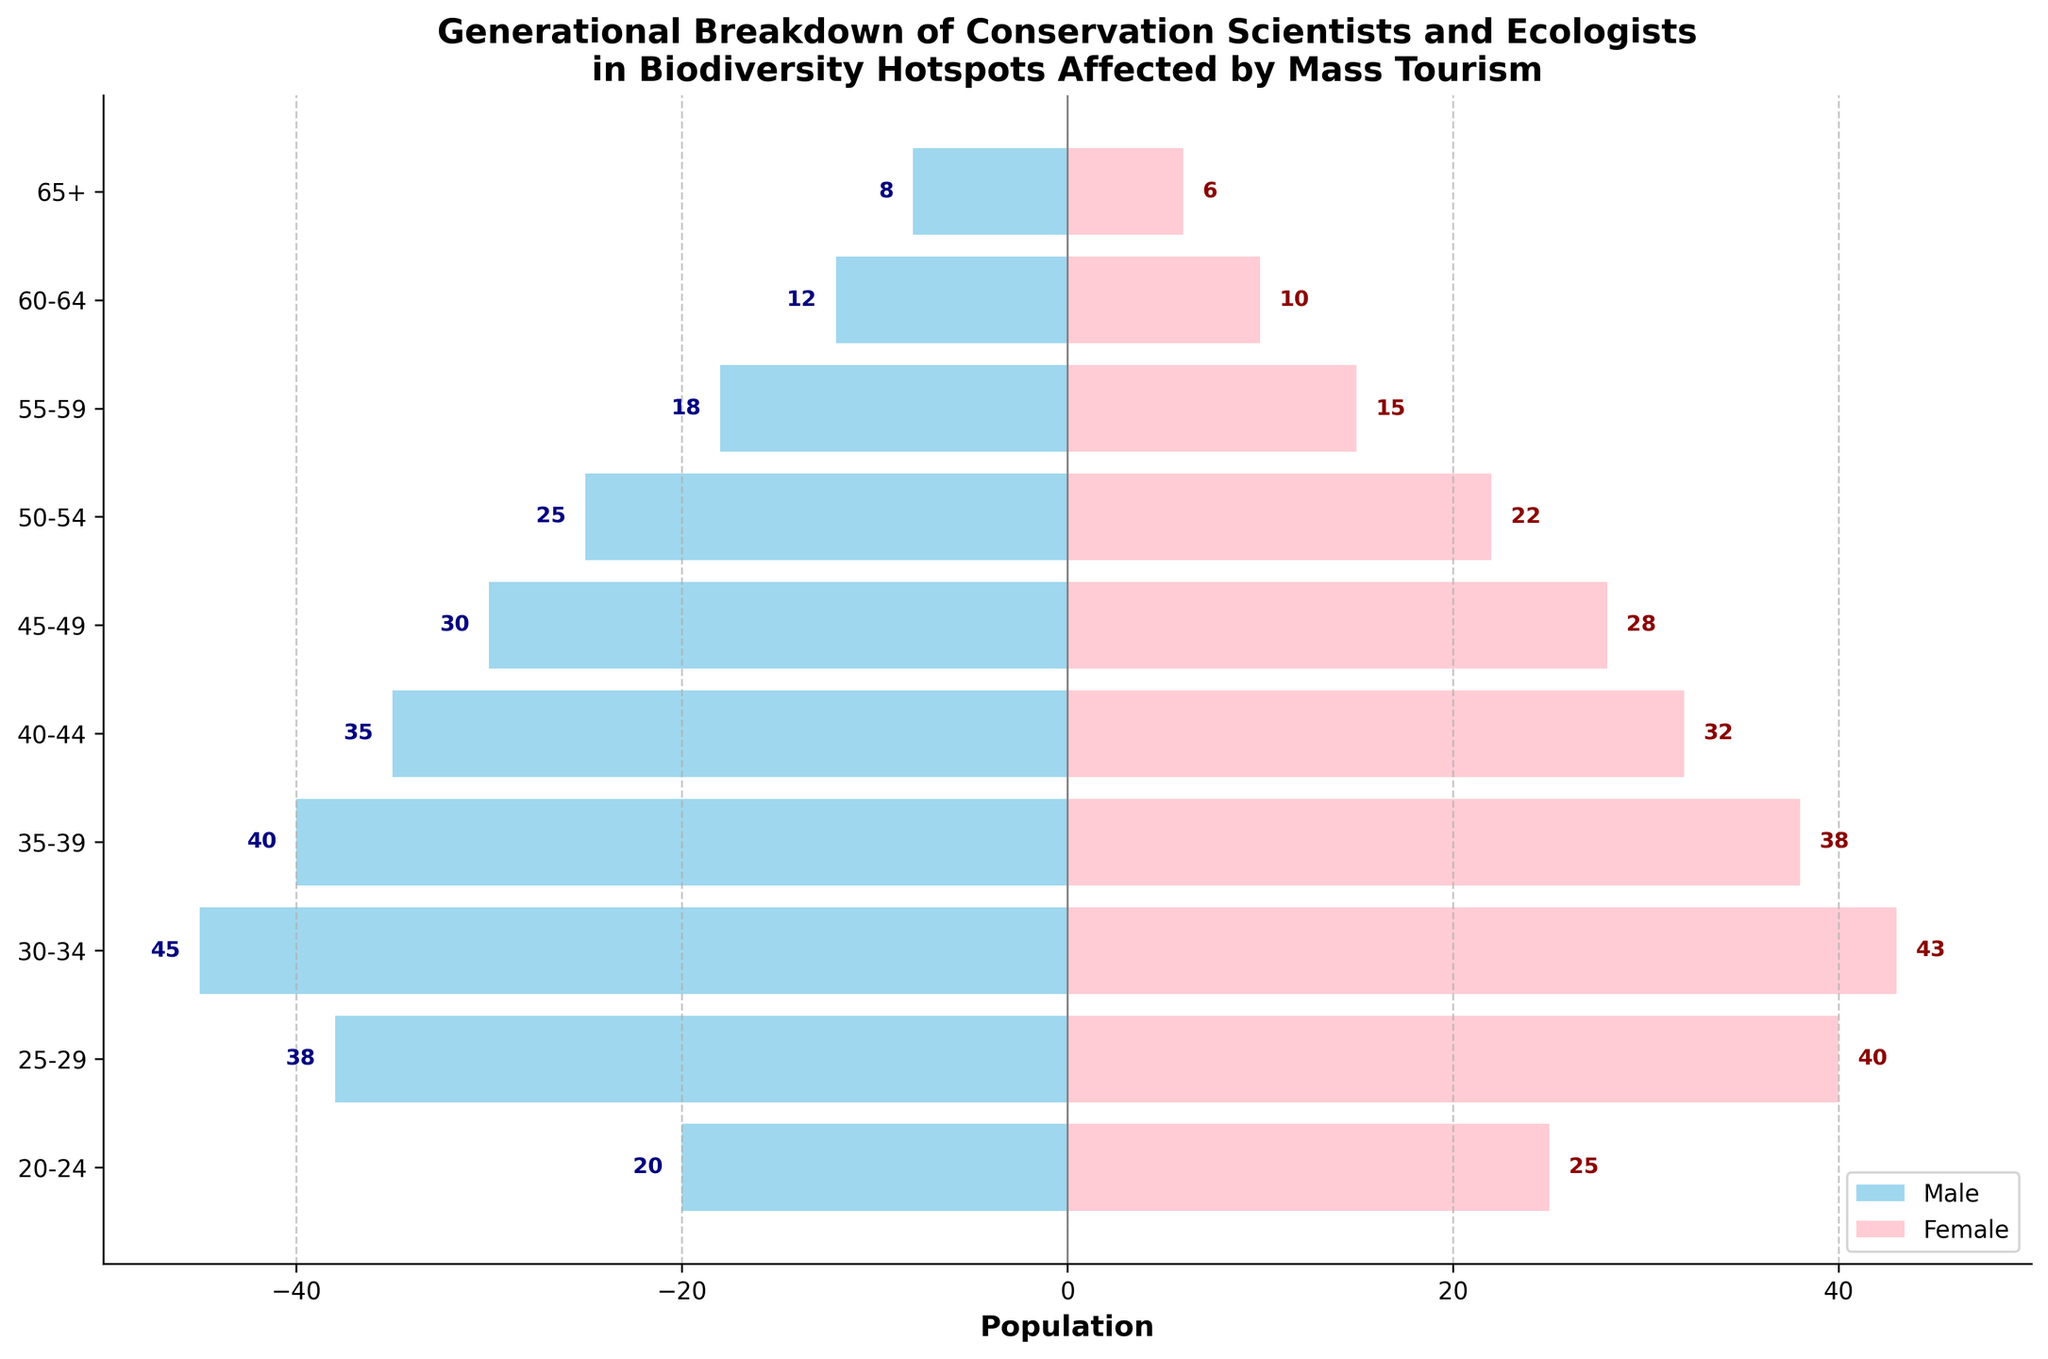Which age group has the highest number of female conservation scientists? Refer to the labels on the x-axis for female scientists and check the corresponding age group with the longest pink bar. The 30-34 age group has the highest number of female scientists.
Answer: 30-34 What's the total number of male conservation scientists in the 25-29 and 30-34 age groups? Look at the length of the sky-blue bars corresponding to the 25-29 and 30-34 age groups on the left side. Sum up the male values for these two age groups: 38 (25-29) + 45 (30-34) = 83.
Answer: 83 Compare the number of female conservation scientists aged 20-24 to those aged 25-29. Which group is larger and by how much? Check the length of the pink bars for the 20-24 and 25-29 age groups. The 25-29 group has 40 females, and the 20-24 group has 25 females. The difference is 40 - 25 = 15.
Answer: 25-29, 15 How many more female than male conservation scientists are there in the 20-24 age group? Compare the absolute values of the sky-blue bar (male) and the pink bar (female) in the 20-24 age group. The female value is 25, and the male value is 20. The difference is 25 - 20 = 5.
Answer: 5 What is the combined total of male and female conservation scientists in the 55-59 age group? Multiply the absolute value of the sky-blue bar (male) by -1 and add the pink bar (female). 18 (male) + 15 (female) = 33.
Answer: 33 What is the ratio of male to female conservation scientists in the 45-49 age group? Look at the 45-49 age group, where the male value is 30 and the female value is 28. The ratio is 30:28. Simplify to 15:14.
Answer: 15:14 Which age group has a nearly equal number of male and female conservation scientists? Analyze the visual size for near-equal lengths of the sky-blue and pink bars. The 25-29 age group with male (38) and female (40) is nearly equal.
Answer: 25-29 Is there any age group where the number of male conservation scientists is less than the number of female conservation scientists? Compare the lengths of sky-blue and pink bars for each age group. The 20-24 age group shows males (20) less than females (25).
Answer: 20-24 What is the average number of male conservation scientists across all age groups? Sum up all male values: 8 + 12 + 18 + 25 + 30 + 35 + 40 + 45 + 38 + 20 = 271. Then, divide by the number of age groups (10). Average is 271 / 10 = 27.1.
Answer: 27.1 